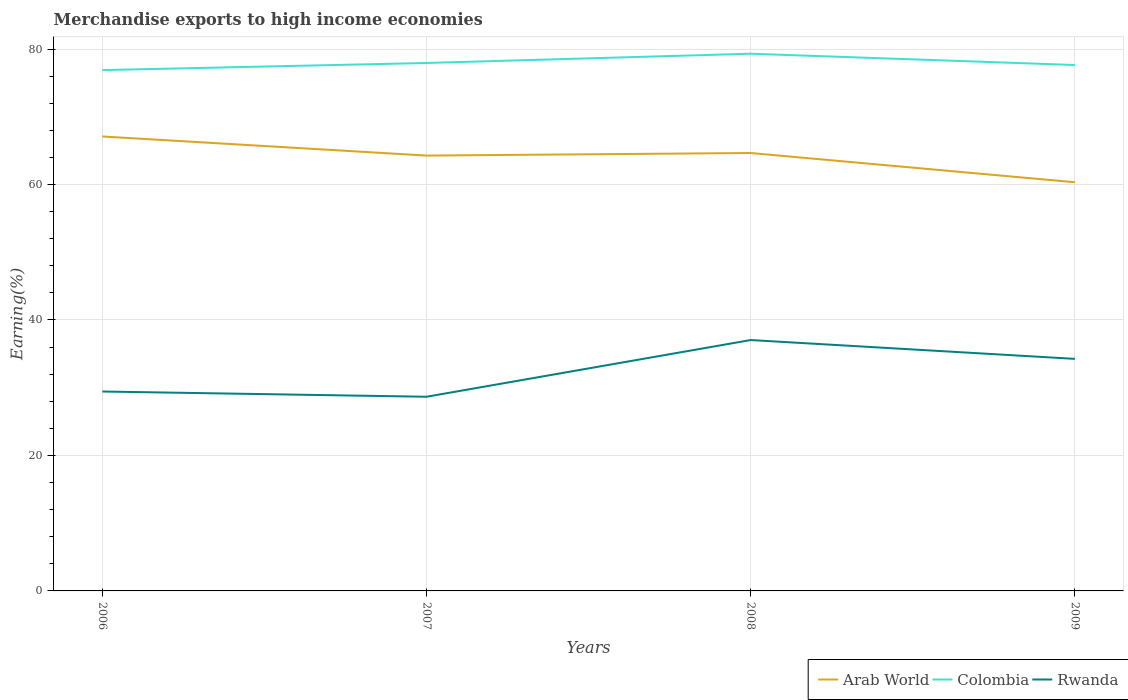How many different coloured lines are there?
Ensure brevity in your answer.  3. Does the line corresponding to Rwanda intersect with the line corresponding to Arab World?
Provide a short and direct response. No. Is the number of lines equal to the number of legend labels?
Your response must be concise. Yes. Across all years, what is the maximum percentage of amount earned from merchandise exports in Rwanda?
Your response must be concise. 28.67. What is the total percentage of amount earned from merchandise exports in Arab World in the graph?
Your answer should be very brief. 4.32. What is the difference between the highest and the second highest percentage of amount earned from merchandise exports in Arab World?
Provide a succinct answer. 6.76. Is the percentage of amount earned from merchandise exports in Arab World strictly greater than the percentage of amount earned from merchandise exports in Rwanda over the years?
Provide a succinct answer. No. How many lines are there?
Make the answer very short. 3. How many years are there in the graph?
Make the answer very short. 4. Are the values on the major ticks of Y-axis written in scientific E-notation?
Your response must be concise. No. Does the graph contain any zero values?
Your answer should be very brief. No. What is the title of the graph?
Provide a succinct answer. Merchandise exports to high income economies. What is the label or title of the Y-axis?
Your response must be concise. Earning(%). What is the Earning(%) of Arab World in 2006?
Your answer should be very brief. 67.09. What is the Earning(%) of Colombia in 2006?
Ensure brevity in your answer.  76.89. What is the Earning(%) in Rwanda in 2006?
Offer a terse response. 29.44. What is the Earning(%) of Arab World in 2007?
Keep it short and to the point. 64.27. What is the Earning(%) of Colombia in 2007?
Give a very brief answer. 77.94. What is the Earning(%) in Rwanda in 2007?
Provide a short and direct response. 28.67. What is the Earning(%) in Arab World in 2008?
Make the answer very short. 64.65. What is the Earning(%) of Colombia in 2008?
Your answer should be compact. 79.31. What is the Earning(%) of Rwanda in 2008?
Your answer should be compact. 37.04. What is the Earning(%) of Arab World in 2009?
Provide a short and direct response. 60.33. What is the Earning(%) of Colombia in 2009?
Offer a very short reply. 77.64. What is the Earning(%) of Rwanda in 2009?
Make the answer very short. 34.26. Across all years, what is the maximum Earning(%) of Arab World?
Provide a short and direct response. 67.09. Across all years, what is the maximum Earning(%) in Colombia?
Give a very brief answer. 79.31. Across all years, what is the maximum Earning(%) in Rwanda?
Give a very brief answer. 37.04. Across all years, what is the minimum Earning(%) of Arab World?
Offer a very short reply. 60.33. Across all years, what is the minimum Earning(%) in Colombia?
Provide a short and direct response. 76.89. Across all years, what is the minimum Earning(%) in Rwanda?
Offer a very short reply. 28.67. What is the total Earning(%) in Arab World in the graph?
Give a very brief answer. 256.35. What is the total Earning(%) in Colombia in the graph?
Provide a short and direct response. 311.79. What is the total Earning(%) in Rwanda in the graph?
Ensure brevity in your answer.  129.4. What is the difference between the Earning(%) of Arab World in 2006 and that in 2007?
Your response must be concise. 2.82. What is the difference between the Earning(%) of Colombia in 2006 and that in 2007?
Give a very brief answer. -1.05. What is the difference between the Earning(%) of Rwanda in 2006 and that in 2007?
Make the answer very short. 0.77. What is the difference between the Earning(%) of Arab World in 2006 and that in 2008?
Provide a short and direct response. 2.44. What is the difference between the Earning(%) of Colombia in 2006 and that in 2008?
Offer a very short reply. -2.42. What is the difference between the Earning(%) of Rwanda in 2006 and that in 2008?
Offer a terse response. -7.6. What is the difference between the Earning(%) of Arab World in 2006 and that in 2009?
Your answer should be compact. 6.76. What is the difference between the Earning(%) in Colombia in 2006 and that in 2009?
Your response must be concise. -0.75. What is the difference between the Earning(%) in Rwanda in 2006 and that in 2009?
Offer a very short reply. -4.82. What is the difference between the Earning(%) of Arab World in 2007 and that in 2008?
Offer a very short reply. -0.38. What is the difference between the Earning(%) in Colombia in 2007 and that in 2008?
Offer a terse response. -1.37. What is the difference between the Earning(%) in Rwanda in 2007 and that in 2008?
Your response must be concise. -8.37. What is the difference between the Earning(%) of Arab World in 2007 and that in 2009?
Provide a succinct answer. 3.94. What is the difference between the Earning(%) of Colombia in 2007 and that in 2009?
Your response must be concise. 0.3. What is the difference between the Earning(%) of Rwanda in 2007 and that in 2009?
Your response must be concise. -5.59. What is the difference between the Earning(%) in Arab World in 2008 and that in 2009?
Your answer should be very brief. 4.32. What is the difference between the Earning(%) of Colombia in 2008 and that in 2009?
Provide a short and direct response. 1.66. What is the difference between the Earning(%) of Rwanda in 2008 and that in 2009?
Make the answer very short. 2.78. What is the difference between the Earning(%) of Arab World in 2006 and the Earning(%) of Colombia in 2007?
Provide a short and direct response. -10.85. What is the difference between the Earning(%) of Arab World in 2006 and the Earning(%) of Rwanda in 2007?
Make the answer very short. 38.43. What is the difference between the Earning(%) in Colombia in 2006 and the Earning(%) in Rwanda in 2007?
Your answer should be very brief. 48.23. What is the difference between the Earning(%) in Arab World in 2006 and the Earning(%) in Colombia in 2008?
Offer a very short reply. -12.22. What is the difference between the Earning(%) of Arab World in 2006 and the Earning(%) of Rwanda in 2008?
Ensure brevity in your answer.  30.06. What is the difference between the Earning(%) in Colombia in 2006 and the Earning(%) in Rwanda in 2008?
Keep it short and to the point. 39.86. What is the difference between the Earning(%) of Arab World in 2006 and the Earning(%) of Colombia in 2009?
Your answer should be very brief. -10.55. What is the difference between the Earning(%) in Arab World in 2006 and the Earning(%) in Rwanda in 2009?
Your answer should be compact. 32.83. What is the difference between the Earning(%) of Colombia in 2006 and the Earning(%) of Rwanda in 2009?
Give a very brief answer. 42.63. What is the difference between the Earning(%) in Arab World in 2007 and the Earning(%) in Colombia in 2008?
Your answer should be very brief. -15.04. What is the difference between the Earning(%) in Arab World in 2007 and the Earning(%) in Rwanda in 2008?
Your answer should be very brief. 27.24. What is the difference between the Earning(%) of Colombia in 2007 and the Earning(%) of Rwanda in 2008?
Make the answer very short. 40.91. What is the difference between the Earning(%) in Arab World in 2007 and the Earning(%) in Colombia in 2009?
Give a very brief answer. -13.37. What is the difference between the Earning(%) in Arab World in 2007 and the Earning(%) in Rwanda in 2009?
Provide a succinct answer. 30.01. What is the difference between the Earning(%) of Colombia in 2007 and the Earning(%) of Rwanda in 2009?
Provide a succinct answer. 43.68. What is the difference between the Earning(%) of Arab World in 2008 and the Earning(%) of Colombia in 2009?
Offer a terse response. -12.99. What is the difference between the Earning(%) in Arab World in 2008 and the Earning(%) in Rwanda in 2009?
Keep it short and to the point. 30.39. What is the difference between the Earning(%) in Colombia in 2008 and the Earning(%) in Rwanda in 2009?
Your response must be concise. 45.05. What is the average Earning(%) in Arab World per year?
Ensure brevity in your answer.  64.09. What is the average Earning(%) of Colombia per year?
Your answer should be very brief. 77.95. What is the average Earning(%) in Rwanda per year?
Give a very brief answer. 32.35. In the year 2006, what is the difference between the Earning(%) of Arab World and Earning(%) of Colombia?
Provide a short and direct response. -9.8. In the year 2006, what is the difference between the Earning(%) in Arab World and Earning(%) in Rwanda?
Give a very brief answer. 37.66. In the year 2006, what is the difference between the Earning(%) in Colombia and Earning(%) in Rwanda?
Provide a succinct answer. 47.45. In the year 2007, what is the difference between the Earning(%) in Arab World and Earning(%) in Colombia?
Offer a terse response. -13.67. In the year 2007, what is the difference between the Earning(%) of Arab World and Earning(%) of Rwanda?
Give a very brief answer. 35.61. In the year 2007, what is the difference between the Earning(%) in Colombia and Earning(%) in Rwanda?
Ensure brevity in your answer.  49.28. In the year 2008, what is the difference between the Earning(%) of Arab World and Earning(%) of Colombia?
Ensure brevity in your answer.  -14.66. In the year 2008, what is the difference between the Earning(%) of Arab World and Earning(%) of Rwanda?
Make the answer very short. 27.61. In the year 2008, what is the difference between the Earning(%) of Colombia and Earning(%) of Rwanda?
Offer a terse response. 42.27. In the year 2009, what is the difference between the Earning(%) in Arab World and Earning(%) in Colombia?
Provide a succinct answer. -17.31. In the year 2009, what is the difference between the Earning(%) of Arab World and Earning(%) of Rwanda?
Give a very brief answer. 26.07. In the year 2009, what is the difference between the Earning(%) in Colombia and Earning(%) in Rwanda?
Provide a short and direct response. 43.39. What is the ratio of the Earning(%) in Arab World in 2006 to that in 2007?
Your response must be concise. 1.04. What is the ratio of the Earning(%) of Colombia in 2006 to that in 2007?
Ensure brevity in your answer.  0.99. What is the ratio of the Earning(%) of Rwanda in 2006 to that in 2007?
Offer a very short reply. 1.03. What is the ratio of the Earning(%) in Arab World in 2006 to that in 2008?
Your answer should be compact. 1.04. What is the ratio of the Earning(%) in Colombia in 2006 to that in 2008?
Make the answer very short. 0.97. What is the ratio of the Earning(%) in Rwanda in 2006 to that in 2008?
Your answer should be compact. 0.79. What is the ratio of the Earning(%) of Arab World in 2006 to that in 2009?
Your response must be concise. 1.11. What is the ratio of the Earning(%) of Colombia in 2006 to that in 2009?
Provide a succinct answer. 0.99. What is the ratio of the Earning(%) in Rwanda in 2006 to that in 2009?
Ensure brevity in your answer.  0.86. What is the ratio of the Earning(%) in Colombia in 2007 to that in 2008?
Keep it short and to the point. 0.98. What is the ratio of the Earning(%) of Rwanda in 2007 to that in 2008?
Make the answer very short. 0.77. What is the ratio of the Earning(%) of Arab World in 2007 to that in 2009?
Provide a short and direct response. 1.07. What is the ratio of the Earning(%) in Colombia in 2007 to that in 2009?
Keep it short and to the point. 1. What is the ratio of the Earning(%) in Rwanda in 2007 to that in 2009?
Your answer should be very brief. 0.84. What is the ratio of the Earning(%) in Arab World in 2008 to that in 2009?
Keep it short and to the point. 1.07. What is the ratio of the Earning(%) in Colombia in 2008 to that in 2009?
Offer a very short reply. 1.02. What is the ratio of the Earning(%) in Rwanda in 2008 to that in 2009?
Offer a terse response. 1.08. What is the difference between the highest and the second highest Earning(%) in Arab World?
Make the answer very short. 2.44. What is the difference between the highest and the second highest Earning(%) in Colombia?
Your answer should be very brief. 1.37. What is the difference between the highest and the second highest Earning(%) of Rwanda?
Give a very brief answer. 2.78. What is the difference between the highest and the lowest Earning(%) of Arab World?
Make the answer very short. 6.76. What is the difference between the highest and the lowest Earning(%) in Colombia?
Offer a terse response. 2.42. What is the difference between the highest and the lowest Earning(%) in Rwanda?
Provide a succinct answer. 8.37. 